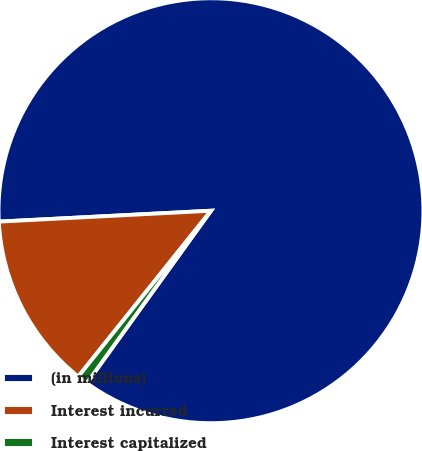Convert chart. <chart><loc_0><loc_0><loc_500><loc_500><pie_chart><fcel>(in millions)<fcel>Interest incurred<fcel>Interest capitalized<nl><fcel>85.74%<fcel>13.44%<fcel>0.81%<nl></chart> 